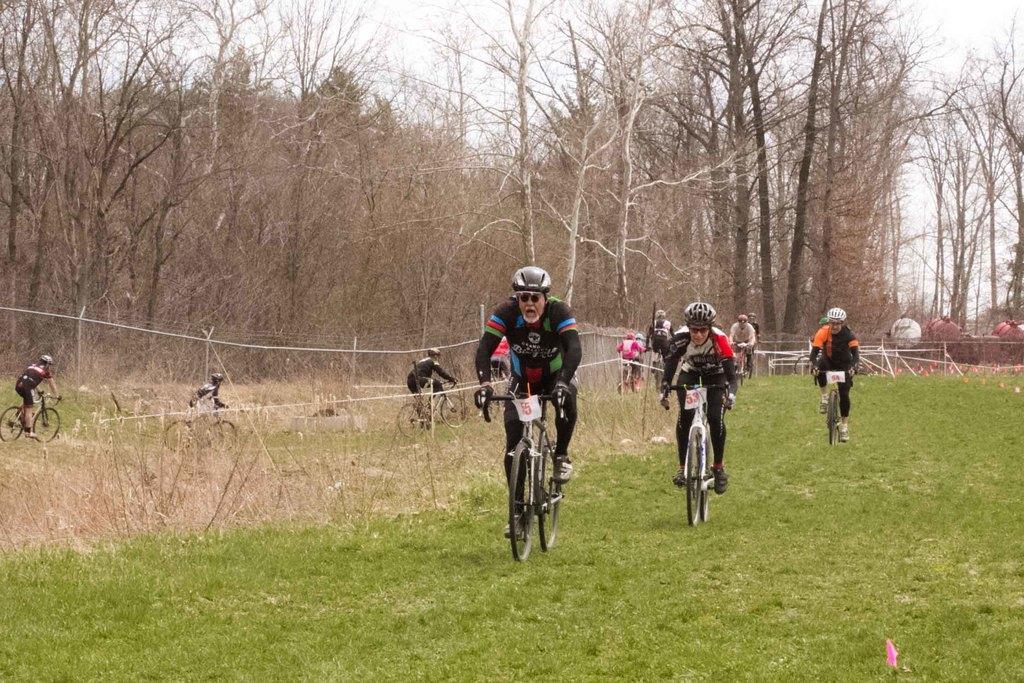Please provide a concise description of this image. In this picture we can see some people riding bicycles, they wore helmets, gloves and shoes, at the bottom there is grass, we can see some trees in the background, there is sky at the top of the picture. 